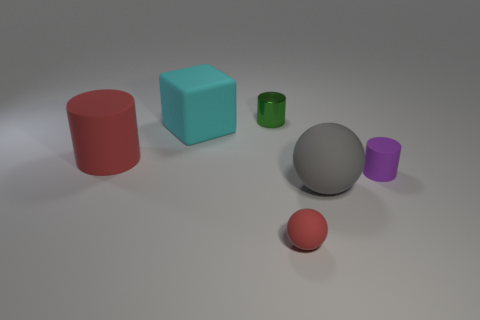Does the small thing that is in front of the gray matte object have the same material as the large cylinder?
Ensure brevity in your answer.  Yes. Is the number of big red objects that are to the left of the large red thing less than the number of rubber cubes?
Provide a succinct answer. Yes. There is a rubber ball that is the same size as the red cylinder; what is its color?
Make the answer very short. Gray. How many cyan rubber things are the same shape as the tiny red rubber object?
Give a very brief answer. 0. There is a large object that is in front of the tiny rubber cylinder; what color is it?
Your response must be concise. Gray. What number of matte things are big cyan cubes or large spheres?
Provide a succinct answer. 2. What shape is the small object that is the same color as the large cylinder?
Provide a short and direct response. Sphere. What number of red rubber spheres have the same size as the green metallic object?
Provide a succinct answer. 1. There is a cylinder that is to the left of the tiny red object and right of the matte block; what is its color?
Provide a short and direct response. Green. What number of objects are big gray rubber spheres or green matte things?
Make the answer very short. 1. 